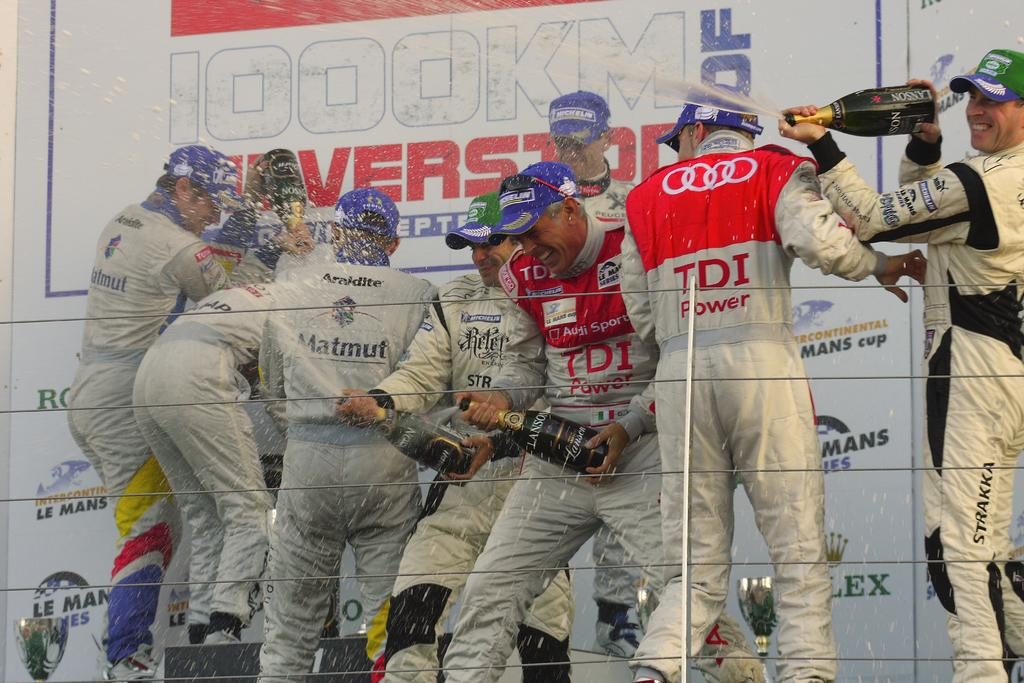<image>
Render a clear and concise summary of the photo. men with tdi power and matmut logos on their outfits spraying champagne 